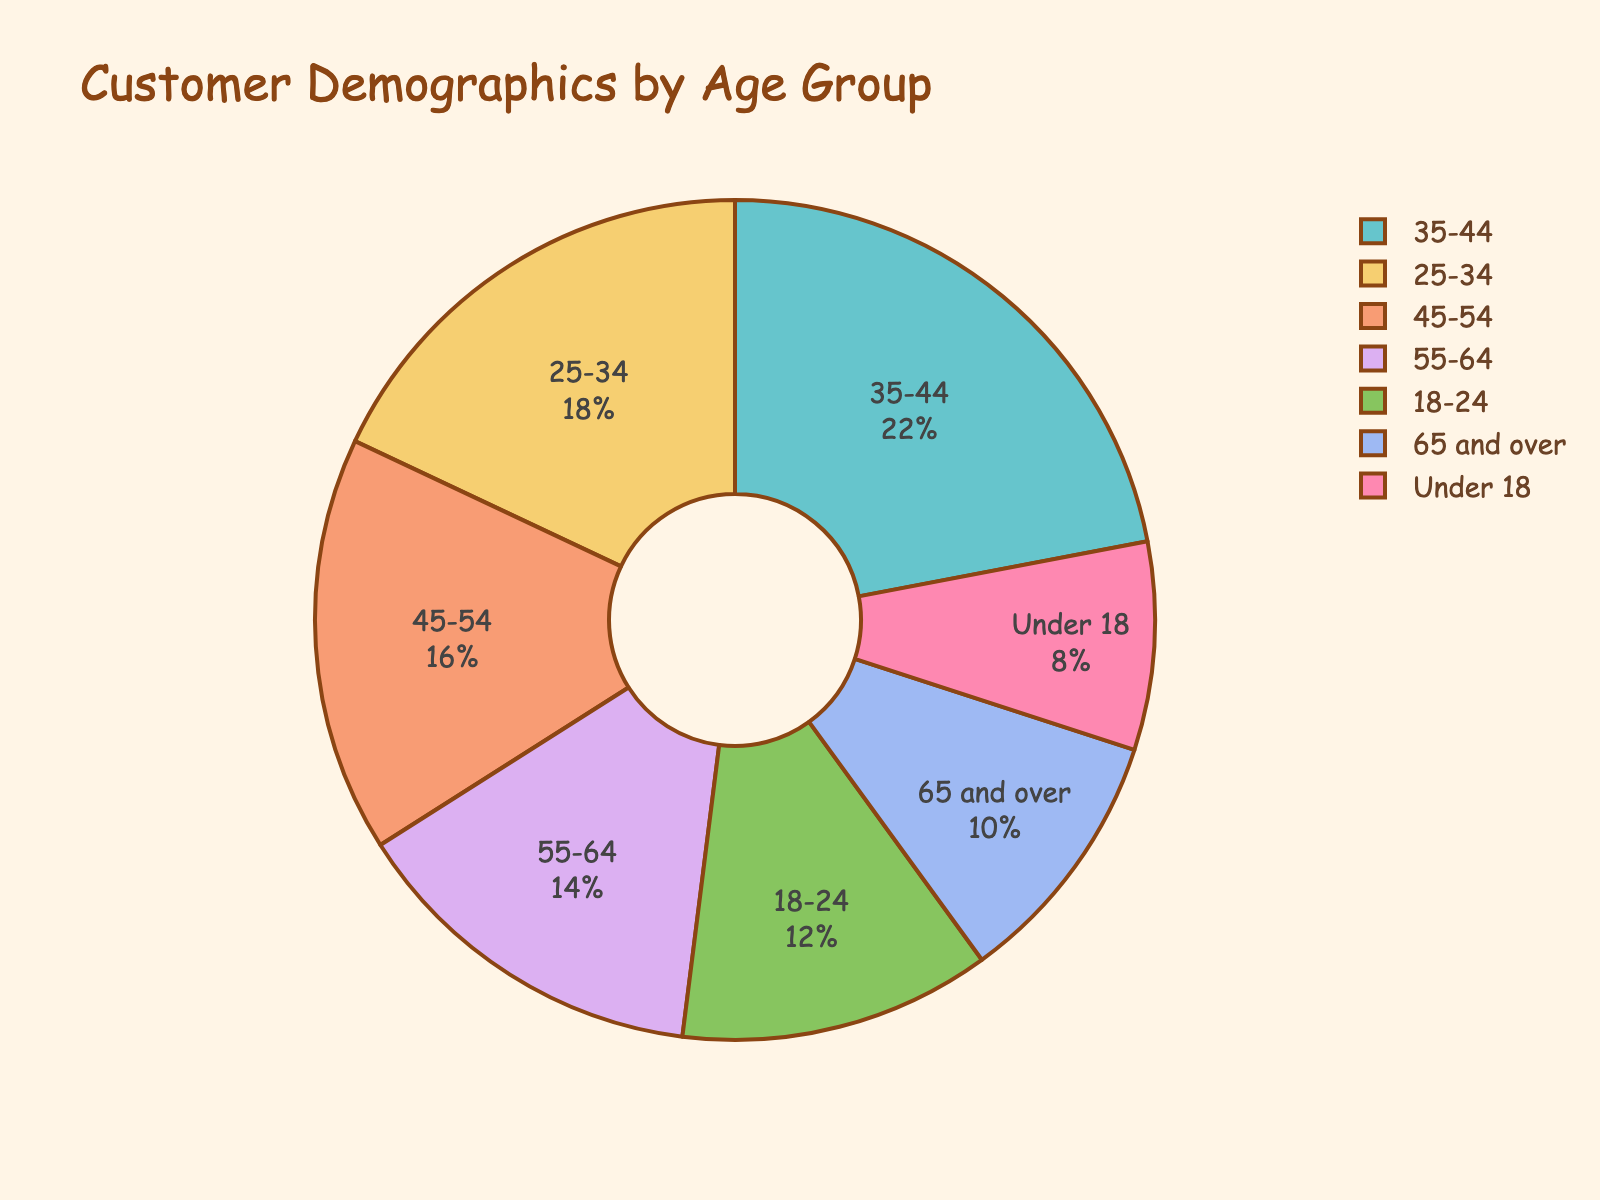What age group has the largest percentage of customers? You can identify the largest percentage by looking at the segments of the pie chart and their respective labeled percentages. The 35-44 age group has the largest segment with a percentage of 22%.
Answer: 35-44 Which two age groups together make up the smallest percentage of customers? First, identify the smallest percentage groups: Under 18 with 8% and 65 and over with 10%. Adding them together, their total is 18%.
Answer: Under 18 and 65 and over Is the percentage of customers aged 18-24 greater than the percentage of those aged 55-64? Compare the labeled percentages of the 18-24 group (12%) and the 55-64 group (14%). The 18-24 group has a smaller percentage than the 55-64 group.
Answer: No What is the total percentage of customers aged 35-54? Add the percentages of the 35-44 age group (22%) and the 45-54 age group (16%). Their total is 22% + 16% = 38%.
Answer: 38% What is the difference in percentage between the 25-34 and 35-44 age groups? Subtract the smaller percentage (25-34 with 18%) from the larger percentage (35-44 with 22%). The difference is 22% - 18% = 4%.
Answer: 4% Among customers aged 18-34, which specific age group has a higher percentage? Compare the 18-24 group (12%) with the 25-34 group (18%). The 25-34 group has a higher percentage.
Answer: 25-34 Is the percentage of customers aged 45-64 equal to the percentage of customers aged 25-44? Add the percentages of the 45-54 group (16%) and the 55-64 group (14%) to get 30%. Add the percentages of the 25-34 group (18%) and the 35-44 group (22%) to get 40%. These totals are not equal.
Answer: No What is the total percentage of customers aged under 25? Add the percentages of the Under 18 group (8%) and the 18-24 group (12%). Their total is 8% + 12% = 20%.
Answer: 20% 